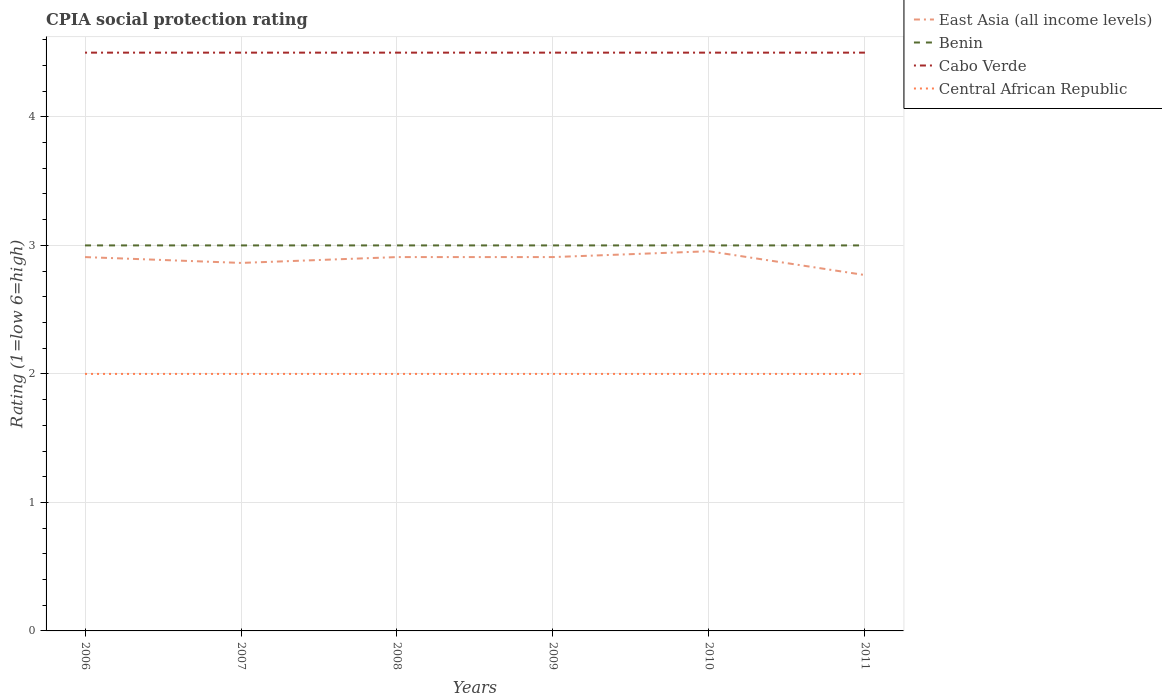Is the number of lines equal to the number of legend labels?
Ensure brevity in your answer.  Yes. Across all years, what is the maximum CPIA rating in Cabo Verde?
Ensure brevity in your answer.  4.5. What is the total CPIA rating in Benin in the graph?
Ensure brevity in your answer.  0. What is the difference between the highest and the second highest CPIA rating in Cabo Verde?
Make the answer very short. 0. Is the CPIA rating in Central African Republic strictly greater than the CPIA rating in East Asia (all income levels) over the years?
Provide a succinct answer. Yes. How many years are there in the graph?
Your answer should be compact. 6. How many legend labels are there?
Your answer should be very brief. 4. What is the title of the graph?
Give a very brief answer. CPIA social protection rating. What is the label or title of the Y-axis?
Your answer should be very brief. Rating (1=low 6=high). What is the Rating (1=low 6=high) in East Asia (all income levels) in 2006?
Make the answer very short. 2.91. What is the Rating (1=low 6=high) of Benin in 2006?
Provide a short and direct response. 3. What is the Rating (1=low 6=high) in Cabo Verde in 2006?
Your answer should be compact. 4.5. What is the Rating (1=low 6=high) in East Asia (all income levels) in 2007?
Give a very brief answer. 2.86. What is the Rating (1=low 6=high) of Benin in 2007?
Offer a terse response. 3. What is the Rating (1=low 6=high) in Cabo Verde in 2007?
Keep it short and to the point. 4.5. What is the Rating (1=low 6=high) in Central African Republic in 2007?
Your answer should be very brief. 2. What is the Rating (1=low 6=high) in East Asia (all income levels) in 2008?
Give a very brief answer. 2.91. What is the Rating (1=low 6=high) of Central African Republic in 2008?
Offer a terse response. 2. What is the Rating (1=low 6=high) in East Asia (all income levels) in 2009?
Keep it short and to the point. 2.91. What is the Rating (1=low 6=high) in Benin in 2009?
Make the answer very short. 3. What is the Rating (1=low 6=high) in Cabo Verde in 2009?
Give a very brief answer. 4.5. What is the Rating (1=low 6=high) of East Asia (all income levels) in 2010?
Offer a very short reply. 2.95. What is the Rating (1=low 6=high) in Benin in 2010?
Make the answer very short. 3. What is the Rating (1=low 6=high) of Cabo Verde in 2010?
Offer a very short reply. 4.5. What is the Rating (1=low 6=high) of Central African Republic in 2010?
Your response must be concise. 2. What is the Rating (1=low 6=high) in East Asia (all income levels) in 2011?
Your response must be concise. 2.77. What is the Rating (1=low 6=high) of Cabo Verde in 2011?
Give a very brief answer. 4.5. What is the Rating (1=low 6=high) in Central African Republic in 2011?
Give a very brief answer. 2. Across all years, what is the maximum Rating (1=low 6=high) of East Asia (all income levels)?
Your response must be concise. 2.95. Across all years, what is the maximum Rating (1=low 6=high) in Benin?
Give a very brief answer. 3. Across all years, what is the maximum Rating (1=low 6=high) in Cabo Verde?
Your response must be concise. 4.5. Across all years, what is the maximum Rating (1=low 6=high) of Central African Republic?
Give a very brief answer. 2. Across all years, what is the minimum Rating (1=low 6=high) in East Asia (all income levels)?
Offer a terse response. 2.77. Across all years, what is the minimum Rating (1=low 6=high) of Benin?
Make the answer very short. 3. Across all years, what is the minimum Rating (1=low 6=high) in Cabo Verde?
Offer a terse response. 4.5. What is the total Rating (1=low 6=high) of East Asia (all income levels) in the graph?
Offer a very short reply. 17.31. What is the total Rating (1=low 6=high) of Benin in the graph?
Offer a terse response. 18. What is the total Rating (1=low 6=high) in Cabo Verde in the graph?
Ensure brevity in your answer.  27. What is the difference between the Rating (1=low 6=high) of East Asia (all income levels) in 2006 and that in 2007?
Your response must be concise. 0.05. What is the difference between the Rating (1=low 6=high) of Central African Republic in 2006 and that in 2007?
Your answer should be compact. 0. What is the difference between the Rating (1=low 6=high) of East Asia (all income levels) in 2006 and that in 2008?
Provide a succinct answer. 0. What is the difference between the Rating (1=low 6=high) of Benin in 2006 and that in 2008?
Your response must be concise. 0. What is the difference between the Rating (1=low 6=high) of Central African Republic in 2006 and that in 2008?
Provide a short and direct response. 0. What is the difference between the Rating (1=low 6=high) in Central African Republic in 2006 and that in 2009?
Your response must be concise. 0. What is the difference between the Rating (1=low 6=high) in East Asia (all income levels) in 2006 and that in 2010?
Give a very brief answer. -0.05. What is the difference between the Rating (1=low 6=high) in Benin in 2006 and that in 2010?
Provide a succinct answer. 0. What is the difference between the Rating (1=low 6=high) in East Asia (all income levels) in 2006 and that in 2011?
Your response must be concise. 0.14. What is the difference between the Rating (1=low 6=high) in East Asia (all income levels) in 2007 and that in 2008?
Provide a short and direct response. -0.05. What is the difference between the Rating (1=low 6=high) in Benin in 2007 and that in 2008?
Give a very brief answer. 0. What is the difference between the Rating (1=low 6=high) in Cabo Verde in 2007 and that in 2008?
Provide a succinct answer. 0. What is the difference between the Rating (1=low 6=high) of Central African Republic in 2007 and that in 2008?
Your answer should be compact. 0. What is the difference between the Rating (1=low 6=high) in East Asia (all income levels) in 2007 and that in 2009?
Your answer should be very brief. -0.05. What is the difference between the Rating (1=low 6=high) in Benin in 2007 and that in 2009?
Give a very brief answer. 0. What is the difference between the Rating (1=low 6=high) in Cabo Verde in 2007 and that in 2009?
Your answer should be very brief. 0. What is the difference between the Rating (1=low 6=high) of East Asia (all income levels) in 2007 and that in 2010?
Provide a short and direct response. -0.09. What is the difference between the Rating (1=low 6=high) in Benin in 2007 and that in 2010?
Your response must be concise. 0. What is the difference between the Rating (1=low 6=high) in East Asia (all income levels) in 2007 and that in 2011?
Give a very brief answer. 0.09. What is the difference between the Rating (1=low 6=high) in Cabo Verde in 2007 and that in 2011?
Offer a terse response. 0. What is the difference between the Rating (1=low 6=high) of Central African Republic in 2007 and that in 2011?
Make the answer very short. 0. What is the difference between the Rating (1=low 6=high) of East Asia (all income levels) in 2008 and that in 2009?
Ensure brevity in your answer.  0. What is the difference between the Rating (1=low 6=high) in East Asia (all income levels) in 2008 and that in 2010?
Provide a short and direct response. -0.05. What is the difference between the Rating (1=low 6=high) of Benin in 2008 and that in 2010?
Offer a terse response. 0. What is the difference between the Rating (1=low 6=high) of Cabo Verde in 2008 and that in 2010?
Provide a short and direct response. 0. What is the difference between the Rating (1=low 6=high) in East Asia (all income levels) in 2008 and that in 2011?
Give a very brief answer. 0.14. What is the difference between the Rating (1=low 6=high) of Cabo Verde in 2008 and that in 2011?
Provide a succinct answer. 0. What is the difference between the Rating (1=low 6=high) of Central African Republic in 2008 and that in 2011?
Your answer should be very brief. 0. What is the difference between the Rating (1=low 6=high) in East Asia (all income levels) in 2009 and that in 2010?
Give a very brief answer. -0.05. What is the difference between the Rating (1=low 6=high) of Cabo Verde in 2009 and that in 2010?
Offer a very short reply. 0. What is the difference between the Rating (1=low 6=high) of Central African Republic in 2009 and that in 2010?
Your answer should be very brief. 0. What is the difference between the Rating (1=low 6=high) of East Asia (all income levels) in 2009 and that in 2011?
Offer a terse response. 0.14. What is the difference between the Rating (1=low 6=high) in East Asia (all income levels) in 2010 and that in 2011?
Your answer should be compact. 0.19. What is the difference between the Rating (1=low 6=high) of East Asia (all income levels) in 2006 and the Rating (1=low 6=high) of Benin in 2007?
Your answer should be very brief. -0.09. What is the difference between the Rating (1=low 6=high) in East Asia (all income levels) in 2006 and the Rating (1=low 6=high) in Cabo Verde in 2007?
Your answer should be very brief. -1.59. What is the difference between the Rating (1=low 6=high) of East Asia (all income levels) in 2006 and the Rating (1=low 6=high) of Benin in 2008?
Offer a very short reply. -0.09. What is the difference between the Rating (1=low 6=high) in East Asia (all income levels) in 2006 and the Rating (1=low 6=high) in Cabo Verde in 2008?
Offer a terse response. -1.59. What is the difference between the Rating (1=low 6=high) of East Asia (all income levels) in 2006 and the Rating (1=low 6=high) of Central African Republic in 2008?
Your response must be concise. 0.91. What is the difference between the Rating (1=low 6=high) of Benin in 2006 and the Rating (1=low 6=high) of Cabo Verde in 2008?
Ensure brevity in your answer.  -1.5. What is the difference between the Rating (1=low 6=high) of Benin in 2006 and the Rating (1=low 6=high) of Central African Republic in 2008?
Give a very brief answer. 1. What is the difference between the Rating (1=low 6=high) of Cabo Verde in 2006 and the Rating (1=low 6=high) of Central African Republic in 2008?
Make the answer very short. 2.5. What is the difference between the Rating (1=low 6=high) in East Asia (all income levels) in 2006 and the Rating (1=low 6=high) in Benin in 2009?
Make the answer very short. -0.09. What is the difference between the Rating (1=low 6=high) in East Asia (all income levels) in 2006 and the Rating (1=low 6=high) in Cabo Verde in 2009?
Offer a very short reply. -1.59. What is the difference between the Rating (1=low 6=high) of Benin in 2006 and the Rating (1=low 6=high) of Central African Republic in 2009?
Offer a very short reply. 1. What is the difference between the Rating (1=low 6=high) in East Asia (all income levels) in 2006 and the Rating (1=low 6=high) in Benin in 2010?
Provide a short and direct response. -0.09. What is the difference between the Rating (1=low 6=high) in East Asia (all income levels) in 2006 and the Rating (1=low 6=high) in Cabo Verde in 2010?
Your answer should be compact. -1.59. What is the difference between the Rating (1=low 6=high) in East Asia (all income levels) in 2006 and the Rating (1=low 6=high) in Benin in 2011?
Ensure brevity in your answer.  -0.09. What is the difference between the Rating (1=low 6=high) in East Asia (all income levels) in 2006 and the Rating (1=low 6=high) in Cabo Verde in 2011?
Keep it short and to the point. -1.59. What is the difference between the Rating (1=low 6=high) in East Asia (all income levels) in 2006 and the Rating (1=low 6=high) in Central African Republic in 2011?
Ensure brevity in your answer.  0.91. What is the difference between the Rating (1=low 6=high) of Benin in 2006 and the Rating (1=low 6=high) of Central African Republic in 2011?
Keep it short and to the point. 1. What is the difference between the Rating (1=low 6=high) in East Asia (all income levels) in 2007 and the Rating (1=low 6=high) in Benin in 2008?
Give a very brief answer. -0.14. What is the difference between the Rating (1=low 6=high) of East Asia (all income levels) in 2007 and the Rating (1=low 6=high) of Cabo Verde in 2008?
Your response must be concise. -1.64. What is the difference between the Rating (1=low 6=high) of East Asia (all income levels) in 2007 and the Rating (1=low 6=high) of Central African Republic in 2008?
Make the answer very short. 0.86. What is the difference between the Rating (1=low 6=high) in Benin in 2007 and the Rating (1=low 6=high) in Cabo Verde in 2008?
Your response must be concise. -1.5. What is the difference between the Rating (1=low 6=high) of Cabo Verde in 2007 and the Rating (1=low 6=high) of Central African Republic in 2008?
Ensure brevity in your answer.  2.5. What is the difference between the Rating (1=low 6=high) of East Asia (all income levels) in 2007 and the Rating (1=low 6=high) of Benin in 2009?
Make the answer very short. -0.14. What is the difference between the Rating (1=low 6=high) of East Asia (all income levels) in 2007 and the Rating (1=low 6=high) of Cabo Verde in 2009?
Ensure brevity in your answer.  -1.64. What is the difference between the Rating (1=low 6=high) of East Asia (all income levels) in 2007 and the Rating (1=low 6=high) of Central African Republic in 2009?
Give a very brief answer. 0.86. What is the difference between the Rating (1=low 6=high) of Cabo Verde in 2007 and the Rating (1=low 6=high) of Central African Republic in 2009?
Make the answer very short. 2.5. What is the difference between the Rating (1=low 6=high) of East Asia (all income levels) in 2007 and the Rating (1=low 6=high) of Benin in 2010?
Keep it short and to the point. -0.14. What is the difference between the Rating (1=low 6=high) in East Asia (all income levels) in 2007 and the Rating (1=low 6=high) in Cabo Verde in 2010?
Provide a succinct answer. -1.64. What is the difference between the Rating (1=low 6=high) in East Asia (all income levels) in 2007 and the Rating (1=low 6=high) in Central African Republic in 2010?
Your answer should be very brief. 0.86. What is the difference between the Rating (1=low 6=high) of Benin in 2007 and the Rating (1=low 6=high) of Cabo Verde in 2010?
Keep it short and to the point. -1.5. What is the difference between the Rating (1=low 6=high) in Benin in 2007 and the Rating (1=low 6=high) in Central African Republic in 2010?
Provide a succinct answer. 1. What is the difference between the Rating (1=low 6=high) in Cabo Verde in 2007 and the Rating (1=low 6=high) in Central African Republic in 2010?
Make the answer very short. 2.5. What is the difference between the Rating (1=low 6=high) of East Asia (all income levels) in 2007 and the Rating (1=low 6=high) of Benin in 2011?
Make the answer very short. -0.14. What is the difference between the Rating (1=low 6=high) of East Asia (all income levels) in 2007 and the Rating (1=low 6=high) of Cabo Verde in 2011?
Your response must be concise. -1.64. What is the difference between the Rating (1=low 6=high) of East Asia (all income levels) in 2007 and the Rating (1=low 6=high) of Central African Republic in 2011?
Make the answer very short. 0.86. What is the difference between the Rating (1=low 6=high) in Benin in 2007 and the Rating (1=low 6=high) in Central African Republic in 2011?
Your answer should be very brief. 1. What is the difference between the Rating (1=low 6=high) in East Asia (all income levels) in 2008 and the Rating (1=low 6=high) in Benin in 2009?
Keep it short and to the point. -0.09. What is the difference between the Rating (1=low 6=high) of East Asia (all income levels) in 2008 and the Rating (1=low 6=high) of Cabo Verde in 2009?
Give a very brief answer. -1.59. What is the difference between the Rating (1=low 6=high) of East Asia (all income levels) in 2008 and the Rating (1=low 6=high) of Central African Republic in 2009?
Ensure brevity in your answer.  0.91. What is the difference between the Rating (1=low 6=high) in East Asia (all income levels) in 2008 and the Rating (1=low 6=high) in Benin in 2010?
Keep it short and to the point. -0.09. What is the difference between the Rating (1=low 6=high) in East Asia (all income levels) in 2008 and the Rating (1=low 6=high) in Cabo Verde in 2010?
Your answer should be compact. -1.59. What is the difference between the Rating (1=low 6=high) in Benin in 2008 and the Rating (1=low 6=high) in Central African Republic in 2010?
Your answer should be compact. 1. What is the difference between the Rating (1=low 6=high) in East Asia (all income levels) in 2008 and the Rating (1=low 6=high) in Benin in 2011?
Give a very brief answer. -0.09. What is the difference between the Rating (1=low 6=high) of East Asia (all income levels) in 2008 and the Rating (1=low 6=high) of Cabo Verde in 2011?
Your answer should be very brief. -1.59. What is the difference between the Rating (1=low 6=high) of Benin in 2008 and the Rating (1=low 6=high) of Cabo Verde in 2011?
Give a very brief answer. -1.5. What is the difference between the Rating (1=low 6=high) in Cabo Verde in 2008 and the Rating (1=low 6=high) in Central African Republic in 2011?
Your answer should be very brief. 2.5. What is the difference between the Rating (1=low 6=high) in East Asia (all income levels) in 2009 and the Rating (1=low 6=high) in Benin in 2010?
Keep it short and to the point. -0.09. What is the difference between the Rating (1=low 6=high) of East Asia (all income levels) in 2009 and the Rating (1=low 6=high) of Cabo Verde in 2010?
Ensure brevity in your answer.  -1.59. What is the difference between the Rating (1=low 6=high) of East Asia (all income levels) in 2009 and the Rating (1=low 6=high) of Central African Republic in 2010?
Your answer should be very brief. 0.91. What is the difference between the Rating (1=low 6=high) in Benin in 2009 and the Rating (1=low 6=high) in Cabo Verde in 2010?
Your response must be concise. -1.5. What is the difference between the Rating (1=low 6=high) in East Asia (all income levels) in 2009 and the Rating (1=low 6=high) in Benin in 2011?
Your response must be concise. -0.09. What is the difference between the Rating (1=low 6=high) of East Asia (all income levels) in 2009 and the Rating (1=low 6=high) of Cabo Verde in 2011?
Give a very brief answer. -1.59. What is the difference between the Rating (1=low 6=high) in East Asia (all income levels) in 2009 and the Rating (1=low 6=high) in Central African Republic in 2011?
Offer a very short reply. 0.91. What is the difference between the Rating (1=low 6=high) of Benin in 2009 and the Rating (1=low 6=high) of Central African Republic in 2011?
Offer a terse response. 1. What is the difference between the Rating (1=low 6=high) of East Asia (all income levels) in 2010 and the Rating (1=low 6=high) of Benin in 2011?
Provide a succinct answer. -0.05. What is the difference between the Rating (1=low 6=high) of East Asia (all income levels) in 2010 and the Rating (1=low 6=high) of Cabo Verde in 2011?
Offer a very short reply. -1.55. What is the difference between the Rating (1=low 6=high) in East Asia (all income levels) in 2010 and the Rating (1=low 6=high) in Central African Republic in 2011?
Your response must be concise. 0.95. What is the difference between the Rating (1=low 6=high) in Benin in 2010 and the Rating (1=low 6=high) in Central African Republic in 2011?
Make the answer very short. 1. What is the difference between the Rating (1=low 6=high) in Cabo Verde in 2010 and the Rating (1=low 6=high) in Central African Republic in 2011?
Provide a short and direct response. 2.5. What is the average Rating (1=low 6=high) in East Asia (all income levels) per year?
Keep it short and to the point. 2.89. What is the average Rating (1=low 6=high) in Benin per year?
Provide a short and direct response. 3. What is the average Rating (1=low 6=high) in Cabo Verde per year?
Make the answer very short. 4.5. What is the average Rating (1=low 6=high) of Central African Republic per year?
Provide a short and direct response. 2. In the year 2006, what is the difference between the Rating (1=low 6=high) of East Asia (all income levels) and Rating (1=low 6=high) of Benin?
Your answer should be compact. -0.09. In the year 2006, what is the difference between the Rating (1=low 6=high) of East Asia (all income levels) and Rating (1=low 6=high) of Cabo Verde?
Offer a very short reply. -1.59. In the year 2006, what is the difference between the Rating (1=low 6=high) in Benin and Rating (1=low 6=high) in Cabo Verde?
Give a very brief answer. -1.5. In the year 2006, what is the difference between the Rating (1=low 6=high) in Benin and Rating (1=low 6=high) in Central African Republic?
Provide a succinct answer. 1. In the year 2006, what is the difference between the Rating (1=low 6=high) in Cabo Verde and Rating (1=low 6=high) in Central African Republic?
Provide a succinct answer. 2.5. In the year 2007, what is the difference between the Rating (1=low 6=high) in East Asia (all income levels) and Rating (1=low 6=high) in Benin?
Keep it short and to the point. -0.14. In the year 2007, what is the difference between the Rating (1=low 6=high) of East Asia (all income levels) and Rating (1=low 6=high) of Cabo Verde?
Provide a succinct answer. -1.64. In the year 2007, what is the difference between the Rating (1=low 6=high) of East Asia (all income levels) and Rating (1=low 6=high) of Central African Republic?
Offer a very short reply. 0.86. In the year 2007, what is the difference between the Rating (1=low 6=high) in Benin and Rating (1=low 6=high) in Central African Republic?
Your answer should be compact. 1. In the year 2007, what is the difference between the Rating (1=low 6=high) of Cabo Verde and Rating (1=low 6=high) of Central African Republic?
Offer a terse response. 2.5. In the year 2008, what is the difference between the Rating (1=low 6=high) of East Asia (all income levels) and Rating (1=low 6=high) of Benin?
Offer a very short reply. -0.09. In the year 2008, what is the difference between the Rating (1=low 6=high) in East Asia (all income levels) and Rating (1=low 6=high) in Cabo Verde?
Make the answer very short. -1.59. In the year 2008, what is the difference between the Rating (1=low 6=high) in Benin and Rating (1=low 6=high) in Cabo Verde?
Give a very brief answer. -1.5. In the year 2008, what is the difference between the Rating (1=low 6=high) of Benin and Rating (1=low 6=high) of Central African Republic?
Your answer should be compact. 1. In the year 2008, what is the difference between the Rating (1=low 6=high) of Cabo Verde and Rating (1=low 6=high) of Central African Republic?
Give a very brief answer. 2.5. In the year 2009, what is the difference between the Rating (1=low 6=high) of East Asia (all income levels) and Rating (1=low 6=high) of Benin?
Offer a very short reply. -0.09. In the year 2009, what is the difference between the Rating (1=low 6=high) of East Asia (all income levels) and Rating (1=low 6=high) of Cabo Verde?
Ensure brevity in your answer.  -1.59. In the year 2009, what is the difference between the Rating (1=low 6=high) of Benin and Rating (1=low 6=high) of Cabo Verde?
Keep it short and to the point. -1.5. In the year 2009, what is the difference between the Rating (1=low 6=high) of Cabo Verde and Rating (1=low 6=high) of Central African Republic?
Provide a short and direct response. 2.5. In the year 2010, what is the difference between the Rating (1=low 6=high) of East Asia (all income levels) and Rating (1=low 6=high) of Benin?
Keep it short and to the point. -0.05. In the year 2010, what is the difference between the Rating (1=low 6=high) of East Asia (all income levels) and Rating (1=low 6=high) of Cabo Verde?
Keep it short and to the point. -1.55. In the year 2010, what is the difference between the Rating (1=low 6=high) of East Asia (all income levels) and Rating (1=low 6=high) of Central African Republic?
Keep it short and to the point. 0.95. In the year 2010, what is the difference between the Rating (1=low 6=high) of Benin and Rating (1=low 6=high) of Central African Republic?
Ensure brevity in your answer.  1. In the year 2010, what is the difference between the Rating (1=low 6=high) of Cabo Verde and Rating (1=low 6=high) of Central African Republic?
Your answer should be very brief. 2.5. In the year 2011, what is the difference between the Rating (1=low 6=high) of East Asia (all income levels) and Rating (1=low 6=high) of Benin?
Your answer should be compact. -0.23. In the year 2011, what is the difference between the Rating (1=low 6=high) in East Asia (all income levels) and Rating (1=low 6=high) in Cabo Verde?
Offer a terse response. -1.73. In the year 2011, what is the difference between the Rating (1=low 6=high) in East Asia (all income levels) and Rating (1=low 6=high) in Central African Republic?
Offer a terse response. 0.77. In the year 2011, what is the difference between the Rating (1=low 6=high) in Benin and Rating (1=low 6=high) in Cabo Verde?
Offer a terse response. -1.5. In the year 2011, what is the difference between the Rating (1=low 6=high) in Benin and Rating (1=low 6=high) in Central African Republic?
Give a very brief answer. 1. What is the ratio of the Rating (1=low 6=high) of East Asia (all income levels) in 2006 to that in 2007?
Provide a short and direct response. 1.02. What is the ratio of the Rating (1=low 6=high) of Benin in 2006 to that in 2007?
Provide a succinct answer. 1. What is the ratio of the Rating (1=low 6=high) in East Asia (all income levels) in 2006 to that in 2008?
Give a very brief answer. 1. What is the ratio of the Rating (1=low 6=high) in East Asia (all income levels) in 2006 to that in 2009?
Ensure brevity in your answer.  1. What is the ratio of the Rating (1=low 6=high) in East Asia (all income levels) in 2006 to that in 2010?
Give a very brief answer. 0.98. What is the ratio of the Rating (1=low 6=high) in Central African Republic in 2006 to that in 2010?
Provide a short and direct response. 1. What is the ratio of the Rating (1=low 6=high) in East Asia (all income levels) in 2006 to that in 2011?
Ensure brevity in your answer.  1.05. What is the ratio of the Rating (1=low 6=high) in Benin in 2006 to that in 2011?
Your answer should be very brief. 1. What is the ratio of the Rating (1=low 6=high) of Cabo Verde in 2006 to that in 2011?
Your response must be concise. 1. What is the ratio of the Rating (1=low 6=high) of Central African Republic in 2006 to that in 2011?
Offer a very short reply. 1. What is the ratio of the Rating (1=low 6=high) in East Asia (all income levels) in 2007 to that in 2008?
Provide a short and direct response. 0.98. What is the ratio of the Rating (1=low 6=high) in Benin in 2007 to that in 2008?
Offer a very short reply. 1. What is the ratio of the Rating (1=low 6=high) in Cabo Verde in 2007 to that in 2008?
Your answer should be very brief. 1. What is the ratio of the Rating (1=low 6=high) of Central African Republic in 2007 to that in 2008?
Your answer should be compact. 1. What is the ratio of the Rating (1=low 6=high) of East Asia (all income levels) in 2007 to that in 2009?
Provide a short and direct response. 0.98. What is the ratio of the Rating (1=low 6=high) of Central African Republic in 2007 to that in 2009?
Keep it short and to the point. 1. What is the ratio of the Rating (1=low 6=high) of East Asia (all income levels) in 2007 to that in 2010?
Give a very brief answer. 0.97. What is the ratio of the Rating (1=low 6=high) of Benin in 2007 to that in 2010?
Offer a very short reply. 1. What is the ratio of the Rating (1=low 6=high) in Cabo Verde in 2007 to that in 2010?
Ensure brevity in your answer.  1. What is the ratio of the Rating (1=low 6=high) of East Asia (all income levels) in 2007 to that in 2011?
Your answer should be compact. 1.03. What is the ratio of the Rating (1=low 6=high) of Benin in 2007 to that in 2011?
Your answer should be very brief. 1. What is the ratio of the Rating (1=low 6=high) in Central African Republic in 2007 to that in 2011?
Your answer should be very brief. 1. What is the ratio of the Rating (1=low 6=high) in East Asia (all income levels) in 2008 to that in 2009?
Ensure brevity in your answer.  1. What is the ratio of the Rating (1=low 6=high) of Benin in 2008 to that in 2009?
Keep it short and to the point. 1. What is the ratio of the Rating (1=low 6=high) of Central African Republic in 2008 to that in 2009?
Give a very brief answer. 1. What is the ratio of the Rating (1=low 6=high) in East Asia (all income levels) in 2008 to that in 2010?
Offer a very short reply. 0.98. What is the ratio of the Rating (1=low 6=high) of Central African Republic in 2008 to that in 2010?
Offer a very short reply. 1. What is the ratio of the Rating (1=low 6=high) in East Asia (all income levels) in 2008 to that in 2011?
Make the answer very short. 1.05. What is the ratio of the Rating (1=low 6=high) in Benin in 2008 to that in 2011?
Provide a succinct answer. 1. What is the ratio of the Rating (1=low 6=high) of East Asia (all income levels) in 2009 to that in 2010?
Offer a very short reply. 0.98. What is the ratio of the Rating (1=low 6=high) of Benin in 2009 to that in 2010?
Your response must be concise. 1. What is the ratio of the Rating (1=low 6=high) of East Asia (all income levels) in 2009 to that in 2011?
Your answer should be compact. 1.05. What is the ratio of the Rating (1=low 6=high) in Cabo Verde in 2009 to that in 2011?
Ensure brevity in your answer.  1. What is the ratio of the Rating (1=low 6=high) of East Asia (all income levels) in 2010 to that in 2011?
Ensure brevity in your answer.  1.07. What is the ratio of the Rating (1=low 6=high) of Cabo Verde in 2010 to that in 2011?
Your answer should be very brief. 1. What is the ratio of the Rating (1=low 6=high) of Central African Republic in 2010 to that in 2011?
Ensure brevity in your answer.  1. What is the difference between the highest and the second highest Rating (1=low 6=high) of East Asia (all income levels)?
Make the answer very short. 0.05. What is the difference between the highest and the lowest Rating (1=low 6=high) in East Asia (all income levels)?
Provide a short and direct response. 0.19. What is the difference between the highest and the lowest Rating (1=low 6=high) in Benin?
Provide a short and direct response. 0. What is the difference between the highest and the lowest Rating (1=low 6=high) in Central African Republic?
Your answer should be compact. 0. 